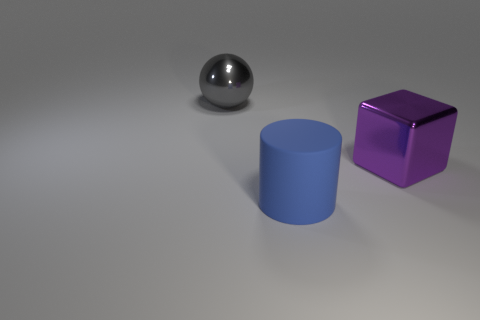What is the material of the big purple cube?
Provide a succinct answer. Metal. There is a gray metallic object; are there any large metallic balls behind it?
Offer a terse response. No. Are there the same number of purple blocks that are in front of the big gray metallic thing and matte cylinders behind the purple block?
Ensure brevity in your answer.  No. How many big brown rubber things are there?
Provide a succinct answer. 0. Is the number of large shiny spheres that are in front of the rubber thing greater than the number of big matte cylinders?
Offer a terse response. No. There is a thing to the left of the blue matte cylinder; what is its material?
Your answer should be compact. Metal. How many large objects are the same color as the large sphere?
Ensure brevity in your answer.  0. Is the size of the metallic thing that is in front of the large gray metal ball the same as the metal object to the left of the purple shiny cube?
Provide a short and direct response. Yes. Is the size of the rubber thing the same as the metal object that is to the right of the big rubber cylinder?
Provide a succinct answer. Yes. What is the size of the matte cylinder?
Make the answer very short. Large. 